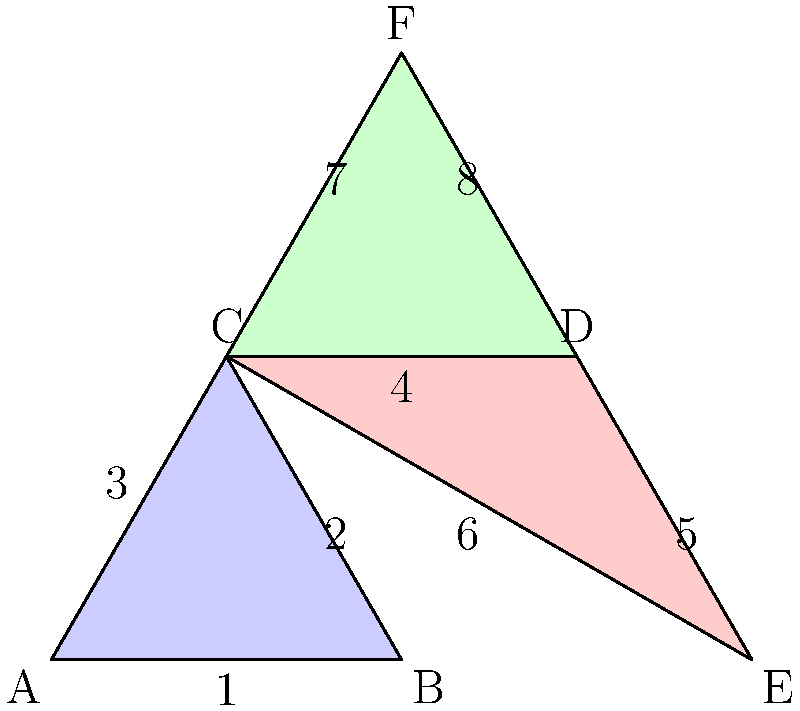In this tessellation pattern of congruent triangles, which side corresponds to side 2 in the green triangle? To solve this problem, we need to follow these steps:

1. Identify the congruent triangles in the tessellation:
   - Blue triangle: ABC
   - Red triangle: CDE
   - Green triangle: CDF

2. Recognize that these triangles are congruent, meaning they have the same shape and size.

3. Identify side 2 in the blue triangle:
   - Side 2 is BC

4. Find the corresponding side in the green triangle:
   - The green triangle (CDF) is rotated 60° counterclockwise compared to the blue triangle (ABC)
   - Side BC in the blue triangle corresponds to side DF in the green triangle

5. Identify the label for side DF in the green triangle:
   - Side DF is labeled as 8

Therefore, side 8 in the green triangle corresponds to side 2 in the blue triangle.
Answer: 8 